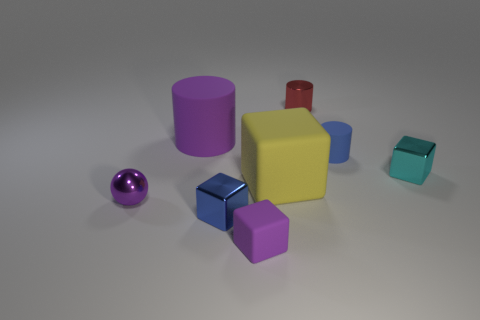Add 2 brown shiny cubes. How many objects exist? 10 Subtract all balls. How many objects are left? 7 Add 5 matte blocks. How many matte blocks are left? 7 Add 4 small green metal cylinders. How many small green metal cylinders exist? 4 Subtract 0 yellow cylinders. How many objects are left? 8 Subtract all tiny blue rubber balls. Subtract all blue things. How many objects are left? 6 